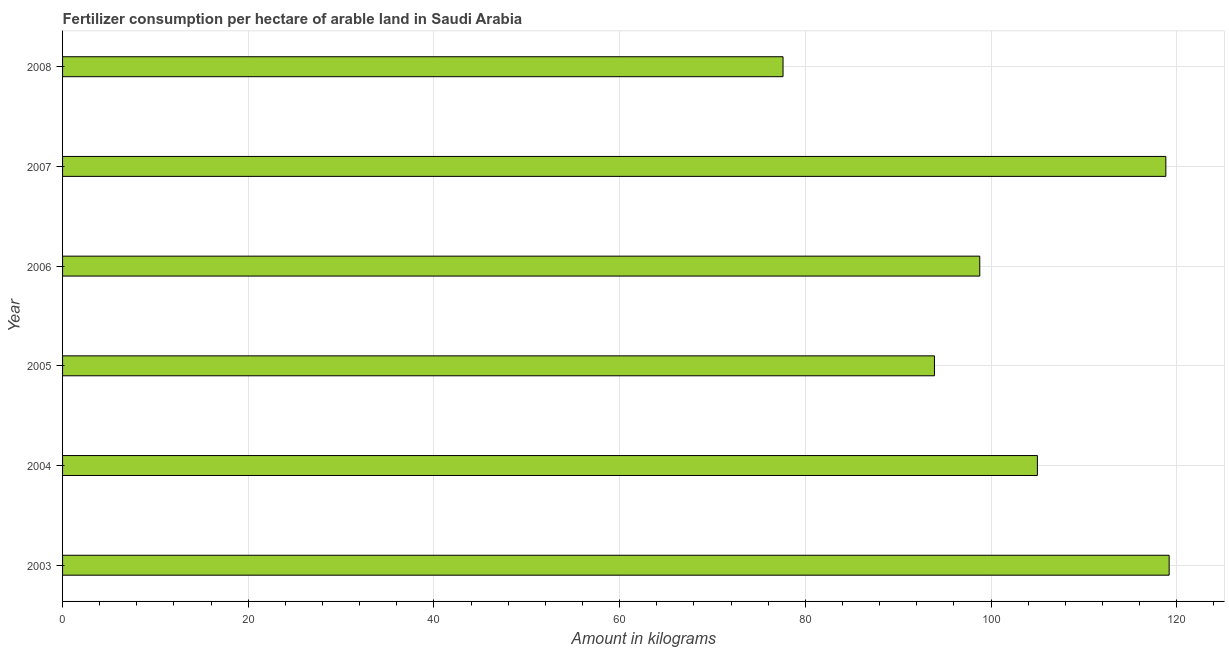What is the title of the graph?
Make the answer very short. Fertilizer consumption per hectare of arable land in Saudi Arabia . What is the label or title of the X-axis?
Make the answer very short. Amount in kilograms. What is the amount of fertilizer consumption in 2008?
Offer a terse response. 77.6. Across all years, what is the maximum amount of fertilizer consumption?
Your response must be concise. 119.18. Across all years, what is the minimum amount of fertilizer consumption?
Your answer should be very brief. 77.6. In which year was the amount of fertilizer consumption maximum?
Your answer should be compact. 2003. In which year was the amount of fertilizer consumption minimum?
Make the answer very short. 2008. What is the sum of the amount of fertilizer consumption?
Give a very brief answer. 613.28. What is the difference between the amount of fertilizer consumption in 2006 and 2007?
Give a very brief answer. -20.04. What is the average amount of fertilizer consumption per year?
Offer a very short reply. 102.21. What is the median amount of fertilizer consumption?
Offer a terse response. 101.89. In how many years, is the amount of fertilizer consumption greater than 88 kg?
Your answer should be compact. 5. What is the ratio of the amount of fertilizer consumption in 2004 to that in 2005?
Your answer should be very brief. 1.12. Is the amount of fertilizer consumption in 2004 less than that in 2005?
Provide a short and direct response. No. Is the difference between the amount of fertilizer consumption in 2005 and 2008 greater than the difference between any two years?
Provide a succinct answer. No. What is the difference between the highest and the second highest amount of fertilizer consumption?
Make the answer very short. 0.36. What is the difference between the highest and the lowest amount of fertilizer consumption?
Give a very brief answer. 41.59. In how many years, is the amount of fertilizer consumption greater than the average amount of fertilizer consumption taken over all years?
Ensure brevity in your answer.  3. How many years are there in the graph?
Make the answer very short. 6. What is the difference between two consecutive major ticks on the X-axis?
Give a very brief answer. 20. What is the Amount in kilograms of 2003?
Give a very brief answer. 119.18. What is the Amount in kilograms in 2004?
Provide a succinct answer. 104.99. What is the Amount in kilograms of 2005?
Give a very brief answer. 93.9. What is the Amount in kilograms in 2006?
Ensure brevity in your answer.  98.78. What is the Amount in kilograms of 2007?
Provide a succinct answer. 118.82. What is the Amount in kilograms in 2008?
Your answer should be very brief. 77.6. What is the difference between the Amount in kilograms in 2003 and 2004?
Keep it short and to the point. 14.19. What is the difference between the Amount in kilograms in 2003 and 2005?
Keep it short and to the point. 25.28. What is the difference between the Amount in kilograms in 2003 and 2006?
Your response must be concise. 20.4. What is the difference between the Amount in kilograms in 2003 and 2007?
Provide a short and direct response. 0.36. What is the difference between the Amount in kilograms in 2003 and 2008?
Offer a very short reply. 41.59. What is the difference between the Amount in kilograms in 2004 and 2005?
Keep it short and to the point. 11.09. What is the difference between the Amount in kilograms in 2004 and 2006?
Provide a short and direct response. 6.21. What is the difference between the Amount in kilograms in 2004 and 2007?
Give a very brief answer. -13.83. What is the difference between the Amount in kilograms in 2004 and 2008?
Your response must be concise. 27.4. What is the difference between the Amount in kilograms in 2005 and 2006?
Ensure brevity in your answer.  -4.88. What is the difference between the Amount in kilograms in 2005 and 2007?
Keep it short and to the point. -24.92. What is the difference between the Amount in kilograms in 2005 and 2008?
Your response must be concise. 16.31. What is the difference between the Amount in kilograms in 2006 and 2007?
Provide a short and direct response. -20.04. What is the difference between the Amount in kilograms in 2006 and 2008?
Offer a very short reply. 21.19. What is the difference between the Amount in kilograms in 2007 and 2008?
Your answer should be very brief. 41.23. What is the ratio of the Amount in kilograms in 2003 to that in 2004?
Keep it short and to the point. 1.14. What is the ratio of the Amount in kilograms in 2003 to that in 2005?
Keep it short and to the point. 1.27. What is the ratio of the Amount in kilograms in 2003 to that in 2006?
Your answer should be compact. 1.21. What is the ratio of the Amount in kilograms in 2003 to that in 2007?
Make the answer very short. 1. What is the ratio of the Amount in kilograms in 2003 to that in 2008?
Provide a succinct answer. 1.54. What is the ratio of the Amount in kilograms in 2004 to that in 2005?
Provide a succinct answer. 1.12. What is the ratio of the Amount in kilograms in 2004 to that in 2006?
Ensure brevity in your answer.  1.06. What is the ratio of the Amount in kilograms in 2004 to that in 2007?
Your answer should be very brief. 0.88. What is the ratio of the Amount in kilograms in 2004 to that in 2008?
Ensure brevity in your answer.  1.35. What is the ratio of the Amount in kilograms in 2005 to that in 2006?
Ensure brevity in your answer.  0.95. What is the ratio of the Amount in kilograms in 2005 to that in 2007?
Give a very brief answer. 0.79. What is the ratio of the Amount in kilograms in 2005 to that in 2008?
Give a very brief answer. 1.21. What is the ratio of the Amount in kilograms in 2006 to that in 2007?
Give a very brief answer. 0.83. What is the ratio of the Amount in kilograms in 2006 to that in 2008?
Ensure brevity in your answer.  1.27. What is the ratio of the Amount in kilograms in 2007 to that in 2008?
Provide a short and direct response. 1.53. 